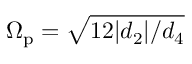Convert formula to latex. <formula><loc_0><loc_0><loc_500><loc_500>\Omega _ { p } = \sqrt { 1 2 | d _ { 2 } | / d _ { 4 } }</formula> 